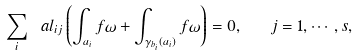Convert formula to latex. <formula><loc_0><loc_0><loc_500><loc_500>\sum _ { i } \ a l _ { i j } \left ( \int _ { a _ { i } } f \omega + \int _ { \gamma _ { b _ { i } } ( a _ { i } ) } f \omega \right ) = 0 , \quad j = 1 , \cdots , s ,</formula> 